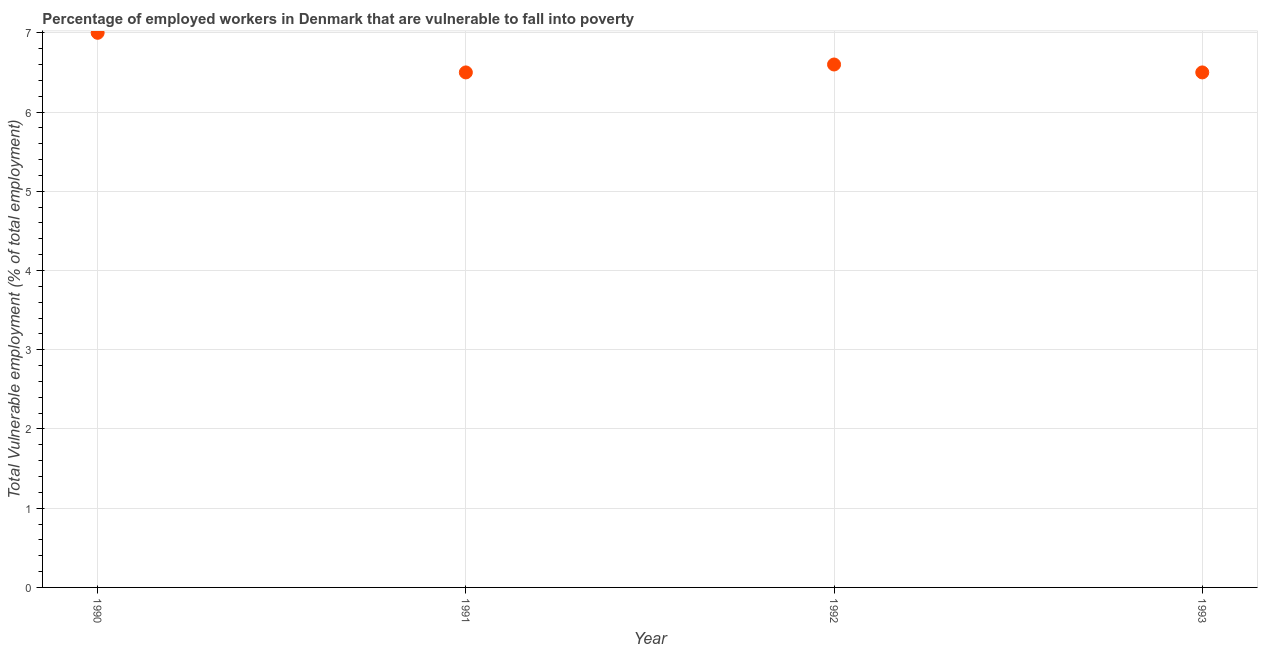Across all years, what is the maximum total vulnerable employment?
Make the answer very short. 7. In which year was the total vulnerable employment minimum?
Make the answer very short. 1991. What is the sum of the total vulnerable employment?
Provide a succinct answer. 26.6. What is the difference between the total vulnerable employment in 1991 and 1993?
Your answer should be very brief. 0. What is the average total vulnerable employment per year?
Your answer should be compact. 6.65. What is the median total vulnerable employment?
Provide a short and direct response. 6.55. What is the ratio of the total vulnerable employment in 1990 to that in 1993?
Ensure brevity in your answer.  1.08. Is the difference between the total vulnerable employment in 1992 and 1993 greater than the difference between any two years?
Ensure brevity in your answer.  No. What is the difference between the highest and the second highest total vulnerable employment?
Make the answer very short. 0.4. Is the sum of the total vulnerable employment in 1990 and 1993 greater than the maximum total vulnerable employment across all years?
Make the answer very short. Yes. What is the difference between the highest and the lowest total vulnerable employment?
Provide a short and direct response. 0.5. Does the total vulnerable employment monotonically increase over the years?
Your answer should be very brief. No. How many dotlines are there?
Your response must be concise. 1. How many years are there in the graph?
Give a very brief answer. 4. What is the title of the graph?
Give a very brief answer. Percentage of employed workers in Denmark that are vulnerable to fall into poverty. What is the label or title of the Y-axis?
Offer a terse response. Total Vulnerable employment (% of total employment). What is the Total Vulnerable employment (% of total employment) in 1991?
Offer a very short reply. 6.5. What is the Total Vulnerable employment (% of total employment) in 1992?
Provide a succinct answer. 6.6. What is the difference between the Total Vulnerable employment (% of total employment) in 1990 and 1992?
Offer a terse response. 0.4. What is the difference between the Total Vulnerable employment (% of total employment) in 1991 and 1993?
Ensure brevity in your answer.  0. What is the difference between the Total Vulnerable employment (% of total employment) in 1992 and 1993?
Give a very brief answer. 0.1. What is the ratio of the Total Vulnerable employment (% of total employment) in 1990 to that in 1991?
Your response must be concise. 1.08. What is the ratio of the Total Vulnerable employment (% of total employment) in 1990 to that in 1992?
Provide a short and direct response. 1.06. What is the ratio of the Total Vulnerable employment (% of total employment) in 1990 to that in 1993?
Your answer should be very brief. 1.08. What is the ratio of the Total Vulnerable employment (% of total employment) in 1991 to that in 1992?
Your answer should be very brief. 0.98. What is the ratio of the Total Vulnerable employment (% of total employment) in 1991 to that in 1993?
Provide a succinct answer. 1. What is the ratio of the Total Vulnerable employment (% of total employment) in 1992 to that in 1993?
Provide a succinct answer. 1.01. 